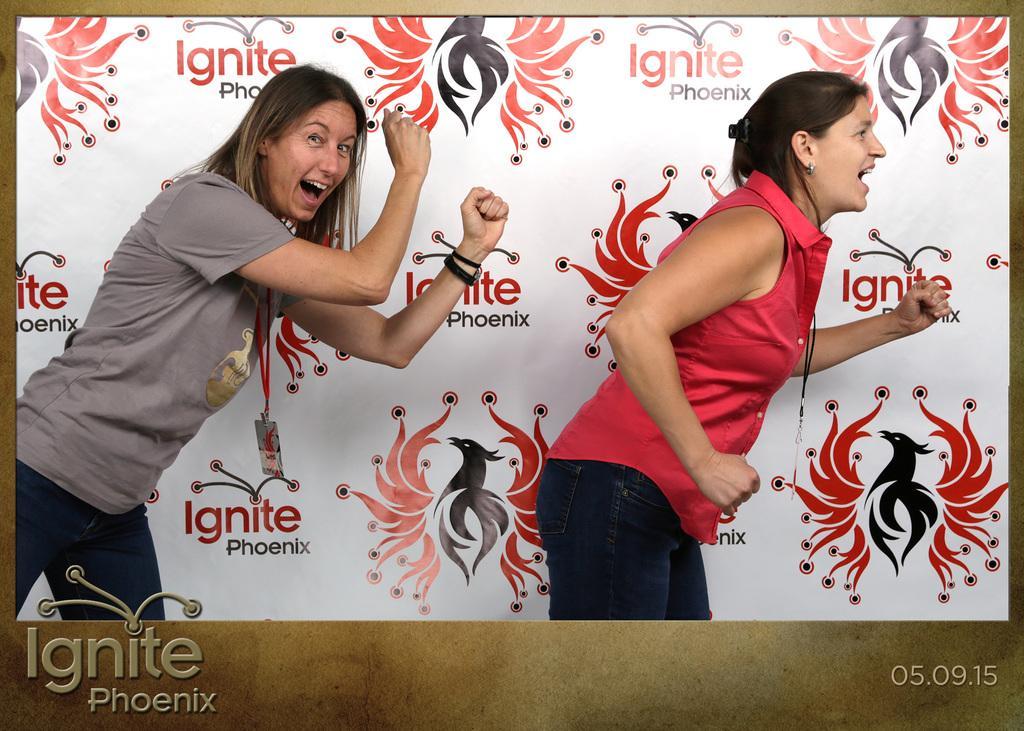How would you summarize this image in a sentence or two? This is a photo. In this picture we can see two ladies are dancing. In the background of the image we can see the board. On the board we can see the text and logos. At the bottom of the image we can see the text. 